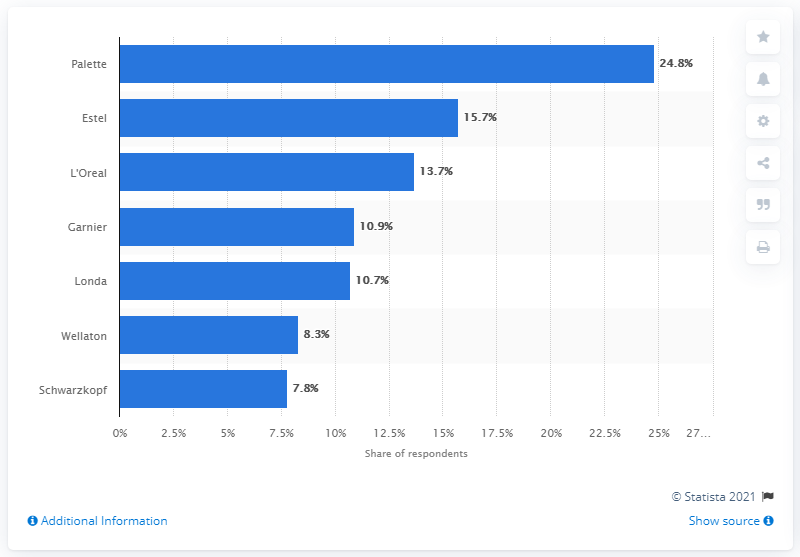Draw attention to some important aspects in this diagram. In 2013, the most popular hair colorant brand in Russia was Palette, according to market research. 